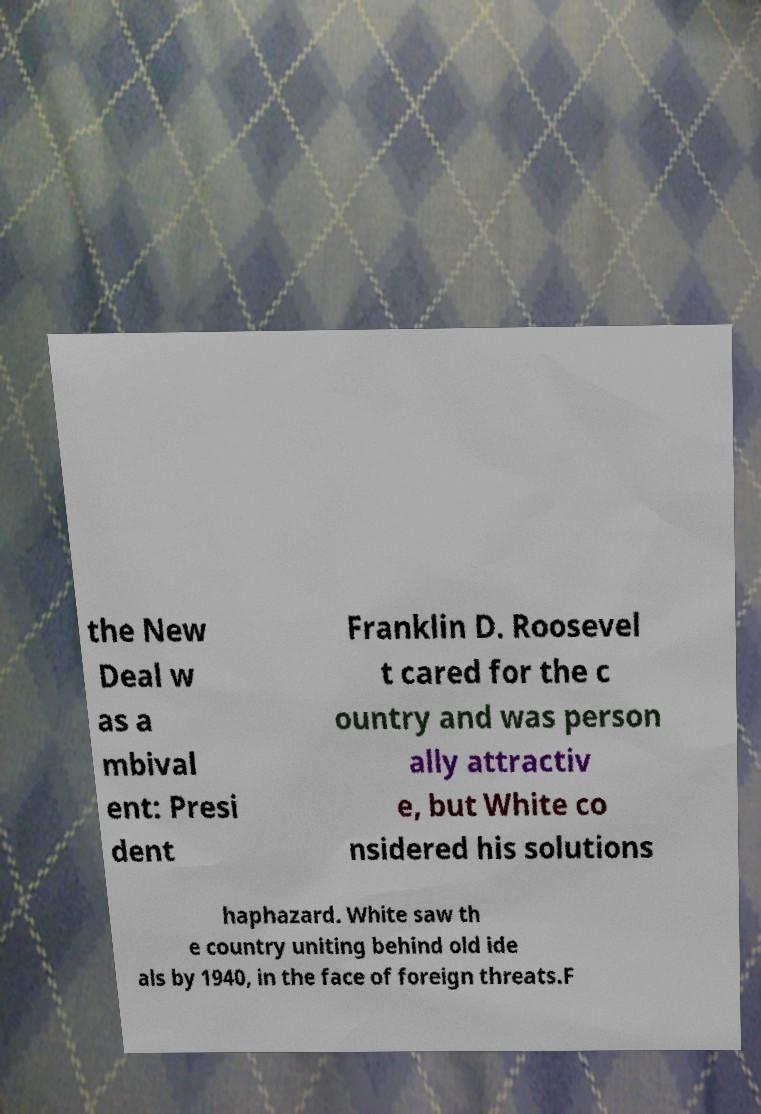I need the written content from this picture converted into text. Can you do that? the New Deal w as a mbival ent: Presi dent Franklin D. Roosevel t cared for the c ountry and was person ally attractiv e, but White co nsidered his solutions haphazard. White saw th e country uniting behind old ide als by 1940, in the face of foreign threats.F 